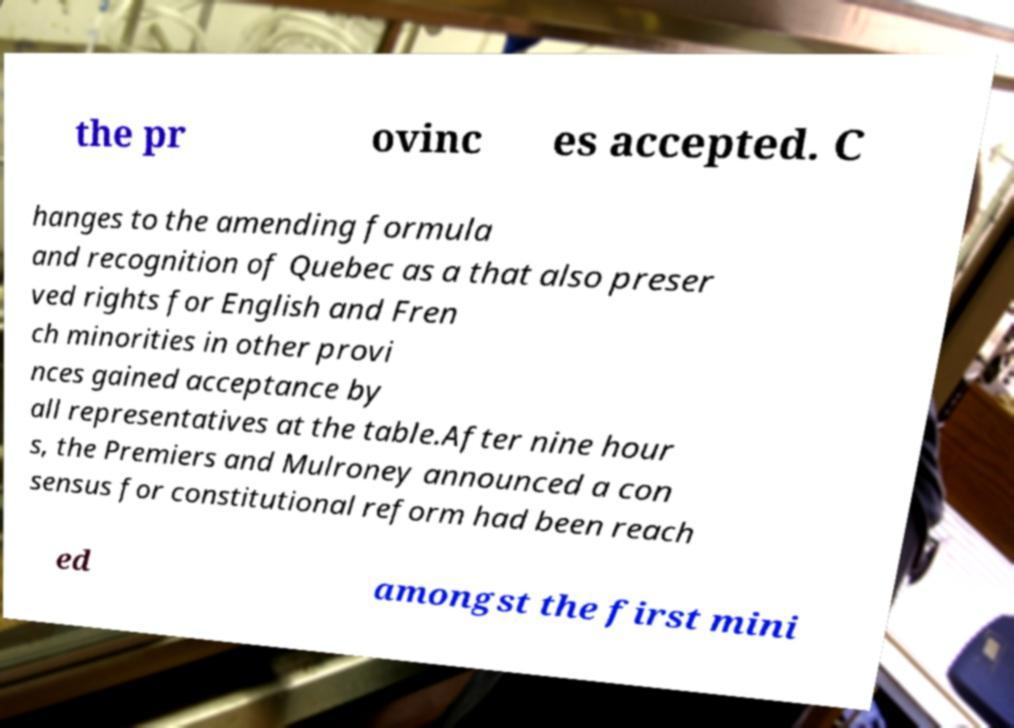Please identify and transcribe the text found in this image. the pr ovinc es accepted. C hanges to the amending formula and recognition of Quebec as a that also preser ved rights for English and Fren ch minorities in other provi nces gained acceptance by all representatives at the table.After nine hour s, the Premiers and Mulroney announced a con sensus for constitutional reform had been reach ed amongst the first mini 